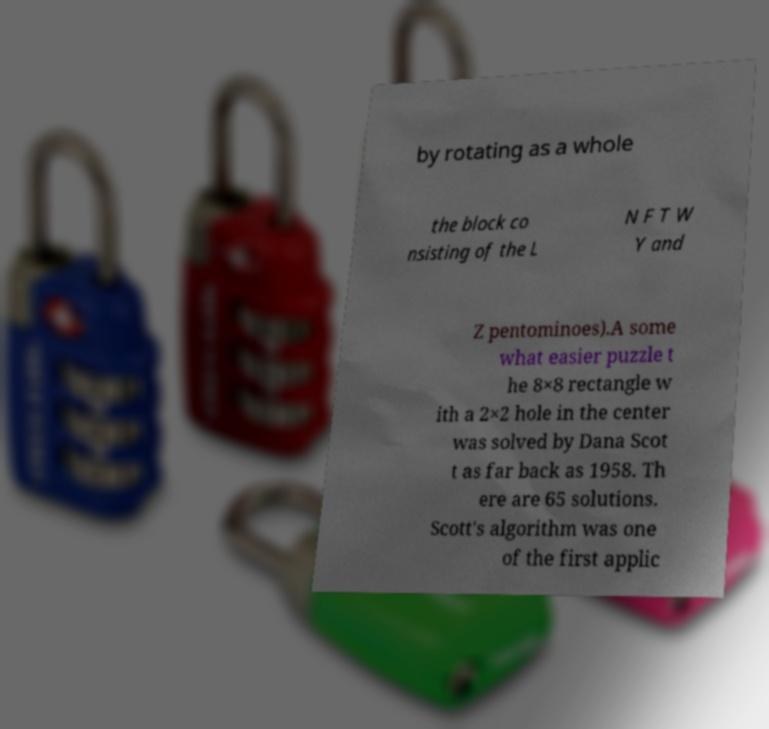Can you read and provide the text displayed in the image?This photo seems to have some interesting text. Can you extract and type it out for me? by rotating as a whole the block co nsisting of the L N F T W Y and Z pentominoes).A some what easier puzzle t he 8×8 rectangle w ith a 2×2 hole in the center was solved by Dana Scot t as far back as 1958. Th ere are 65 solutions. Scott's algorithm was one of the first applic 